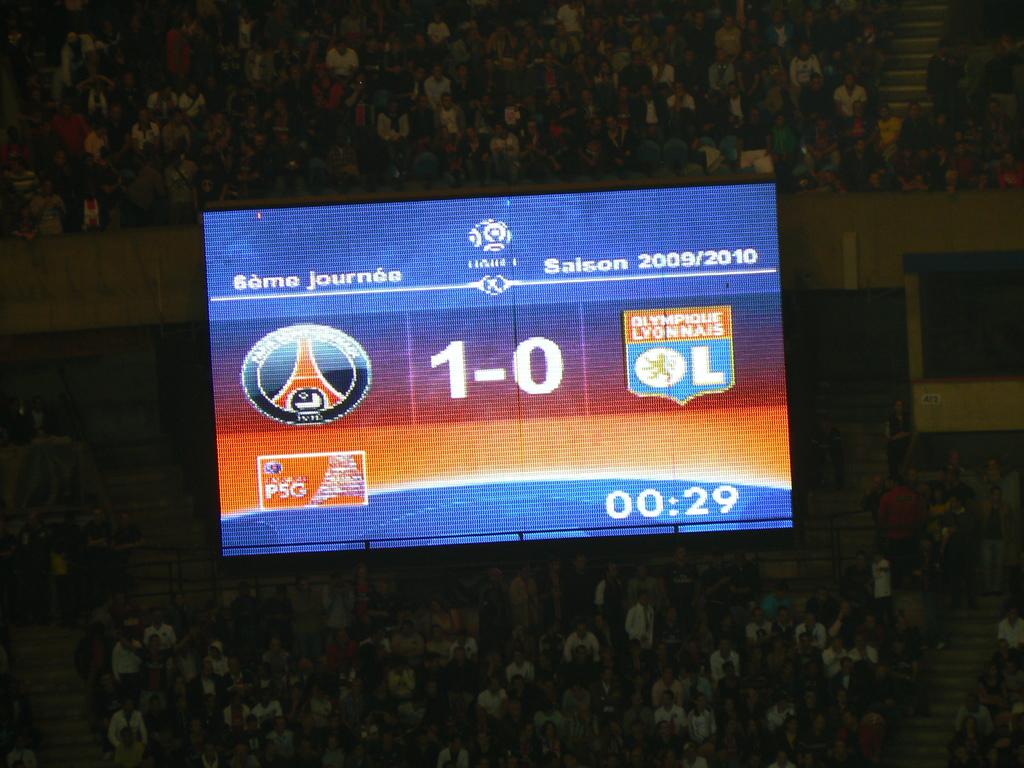How many seconds are left?
Give a very brief answer. 29. What is the score?
Your answer should be compact. 1-0. 